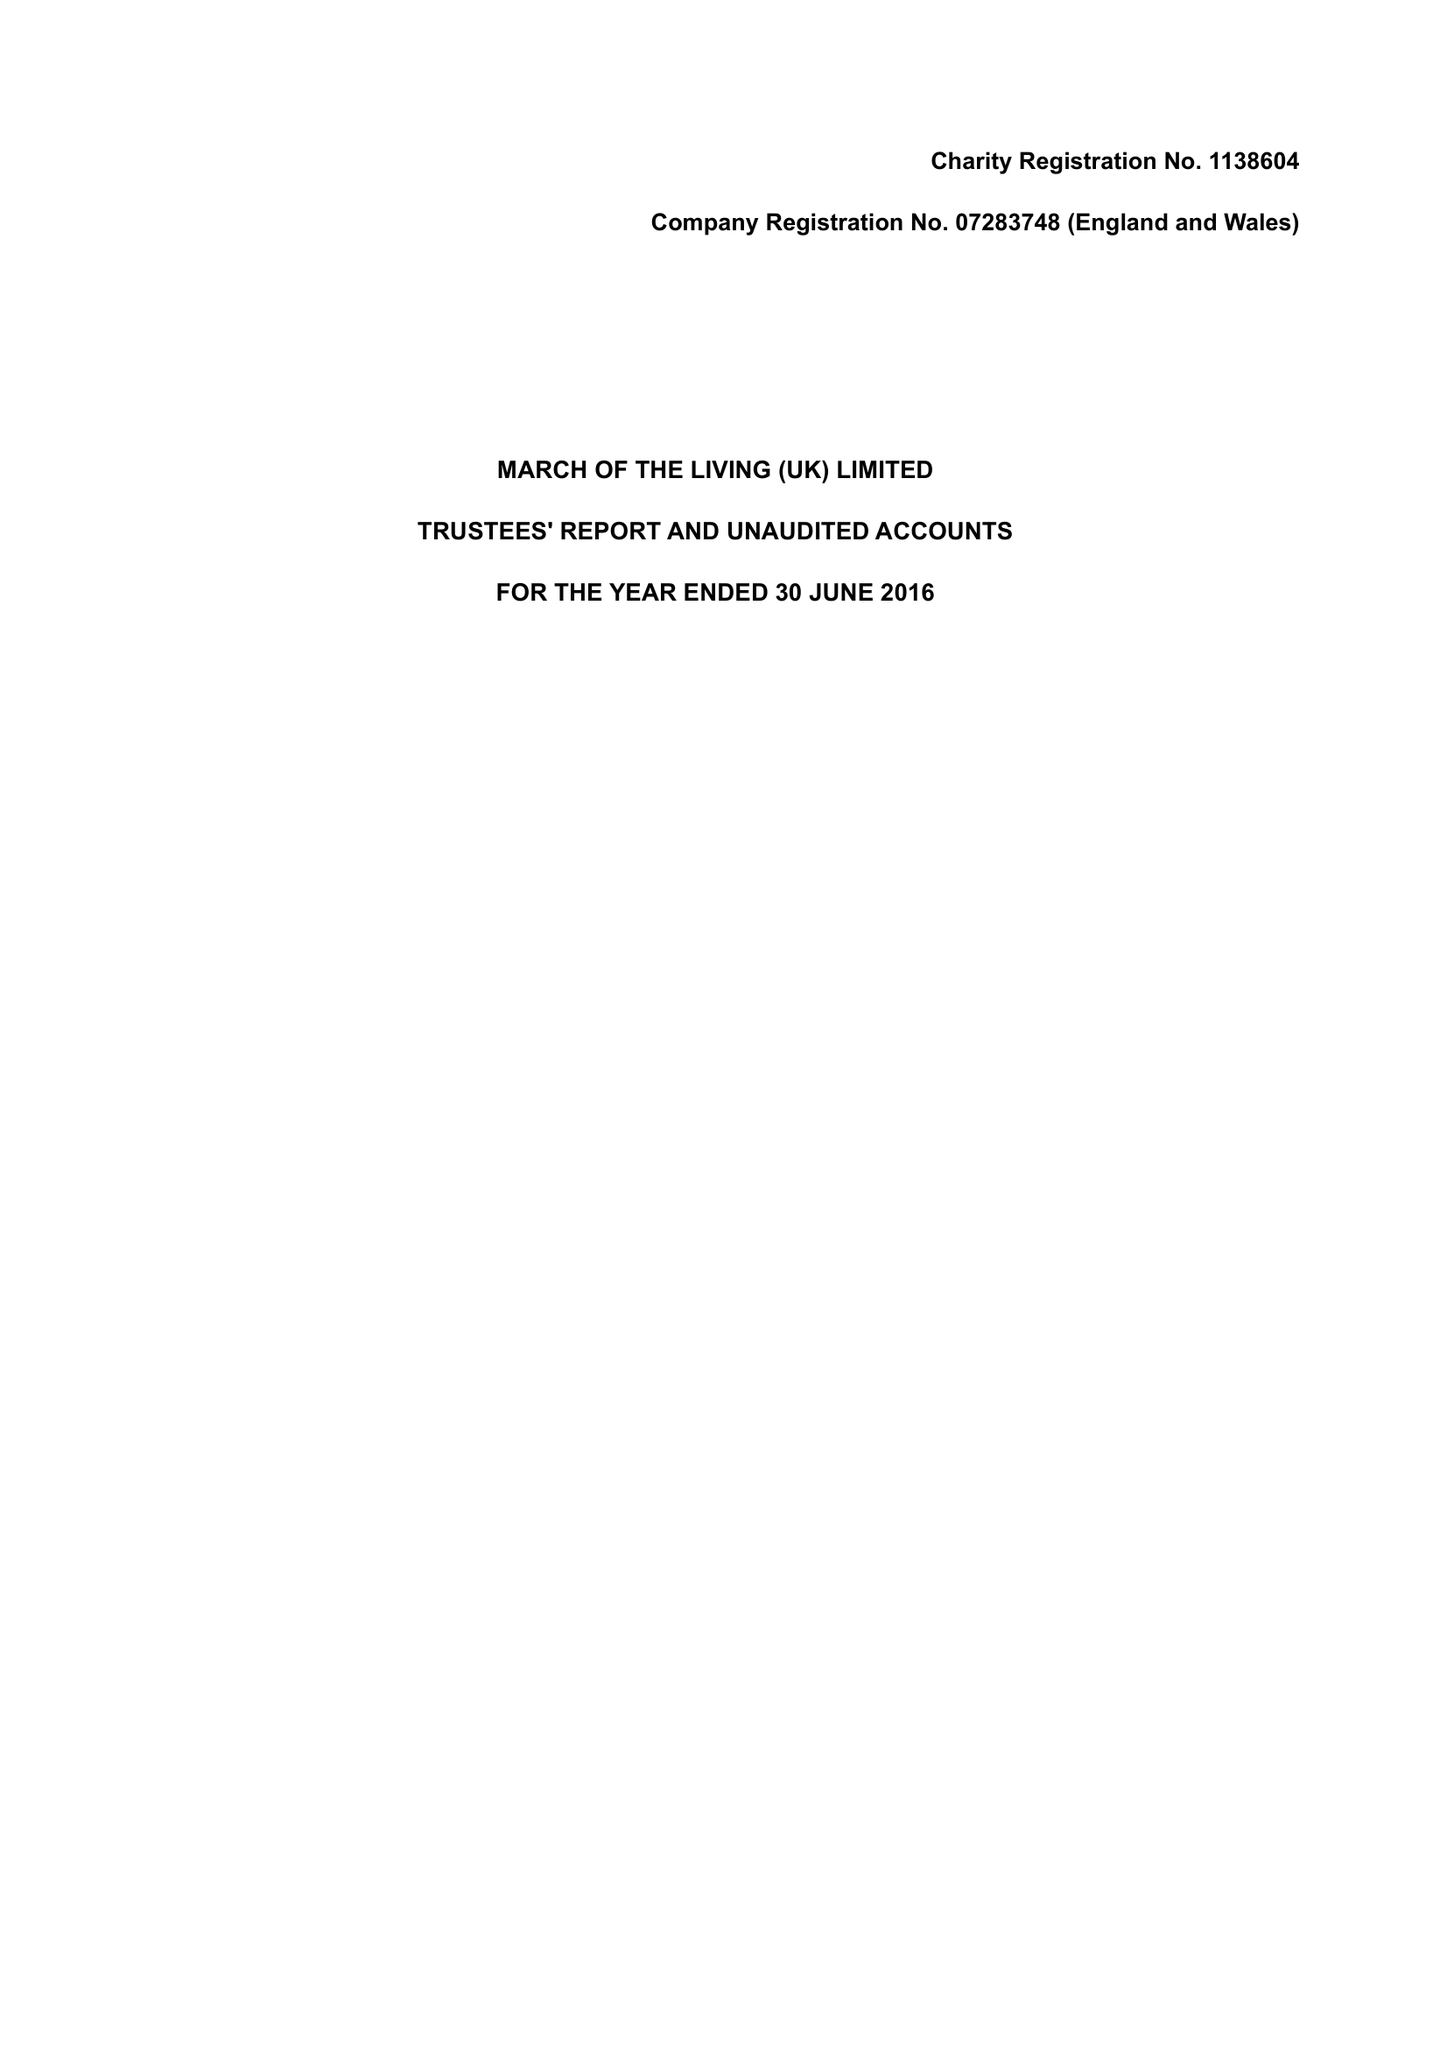What is the value for the spending_annually_in_british_pounds?
Answer the question using a single word or phrase. 318328.00 